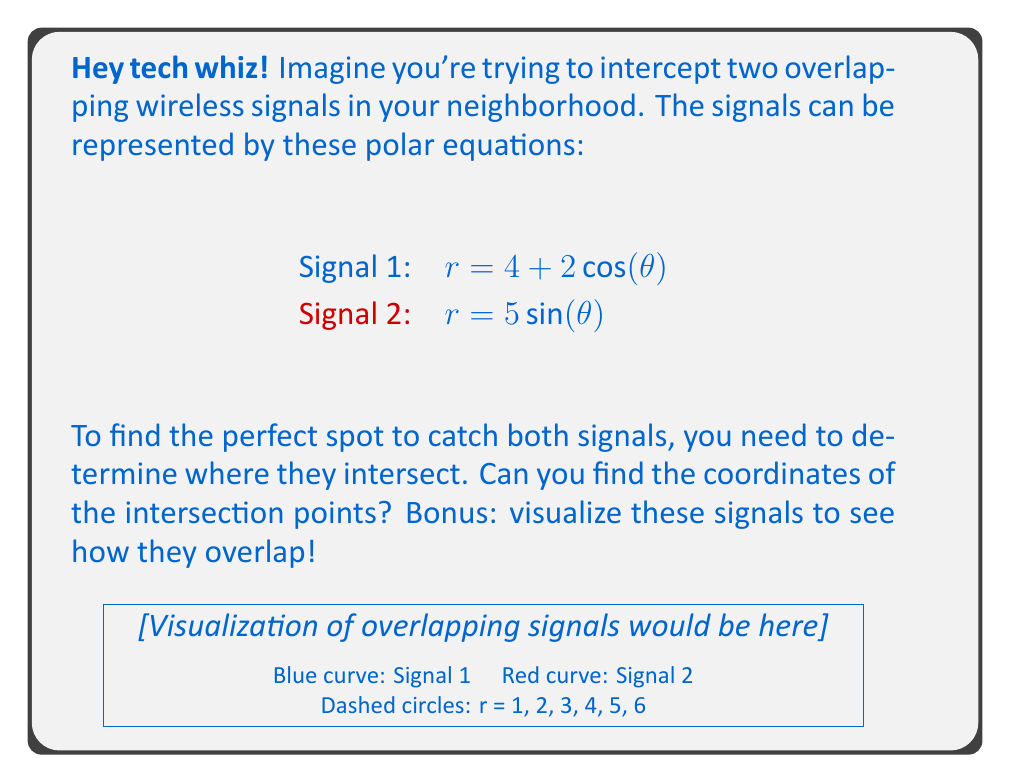Can you answer this question? Alright, let's crack this problem step by step:

1) To find the intersection points, we need to set the two equations equal to each other:

   $4 + 2\cos(\theta) = 5\sin(\theta)$

2) Rearrange the equation:

   $2\cos(\theta) - 5\sin(\theta) = -4$

3) To solve this, let's use the substitution method. Let $\tan(\frac{\theta}{2}) = t$. Then:

   $\cos(\theta) = \frac{1-t^2}{1+t^2}$ and $\sin(\theta) = \frac{2t}{1+t^2}$

4) Substituting these into our equation:

   $2(\frac{1-t^2}{1+t^2}) - 5(\frac{2t}{1+t^2}) = -4$

5) Multiply both sides by $(1+t^2)$:

   $2(1-t^2) - 10t = -4(1+t^2)$

6) Expand:

   $2 - 2t^2 - 10t = -4 - 4t^2$

7) Rearrange:

   $2t^2 - 10t + 6 = 0$

8) This is a quadratic equation. Solve using the quadratic formula:

   $t = \frac{10 \pm \sqrt{100 - 48}}{4} = \frac{10 \pm \sqrt{52}}{4}$

9) Simplify:

   $t = \frac{5 \pm \sqrt{13}}{2}$

10) Remember, $t = \tan(\frac{\theta}{2})$, so:

    $\theta = 2\arctan(\frac{5 \pm \sqrt{13}}{2})$

11) Calculate the two values:

    $\theta_1 \approx 2.6779$ radians or $153.43°$
    $\theta_2 \approx 5.7475$ radians or $329.33°$

12) To get the $r$ values, substitute these $\theta$ values into either of the original equations:

    For $\theta_1$: $r \approx 4.6927$
    For $\theta_2$: $r \approx 3.1326$

13) Convert to Cartesian coordinates:

    $(x_1, y_1) = (r_1\cos(\theta_1), r_1\sin(\theta_1)) \approx (-4.1939, 2.1161)$
    $(x_2, y_2) = (r_2\cos(\theta_2), r_2\sin(\theta_2)) \approx (2.6939, -1.6161)$
Answer: $(-4.1939, 2.1161)$ and $(2.6939, -1.6161)$ 